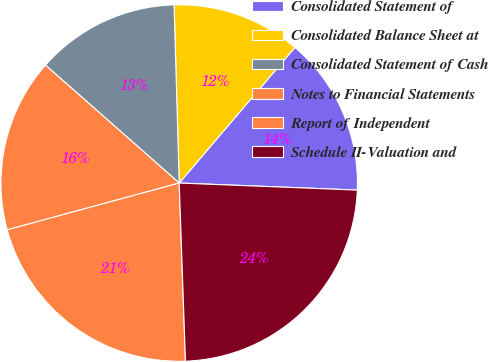Convert chart. <chart><loc_0><loc_0><loc_500><loc_500><pie_chart><fcel>Consolidated Statement of<fcel>Consolidated Balance Sheet at<fcel>Consolidated Statement of Cash<fcel>Notes to Financial Statements<fcel>Report of Independent<fcel>Schedule II-Valuation and<nl><fcel>14.39%<fcel>11.7%<fcel>13.04%<fcel>15.73%<fcel>21.33%<fcel>23.81%<nl></chart> 